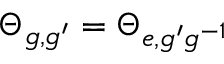Convert formula to latex. <formula><loc_0><loc_0><loc_500><loc_500>\Theta _ { g , g ^ { \prime } } = \Theta _ { e , g ^ { \prime } g ^ { - 1 } }</formula> 